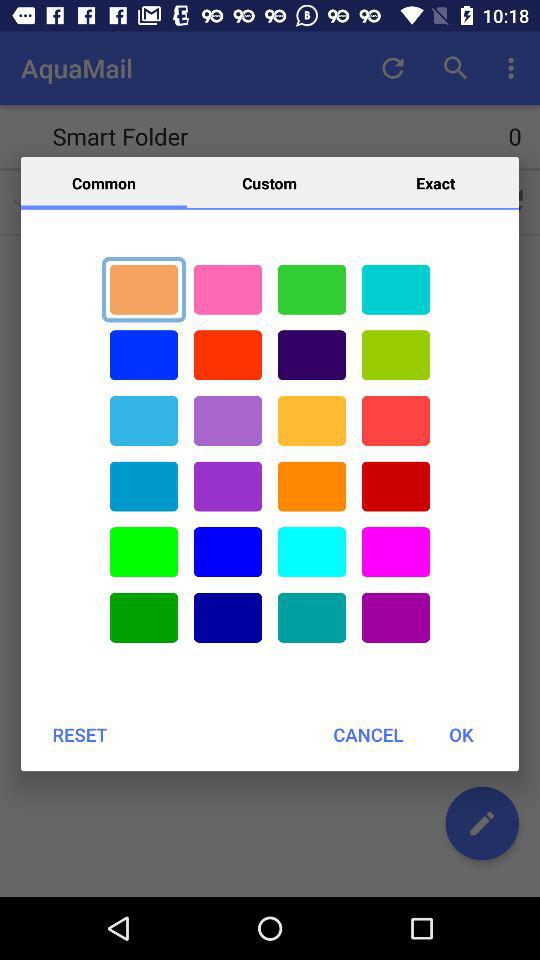What tab is selected? The selected tab is "Common". 